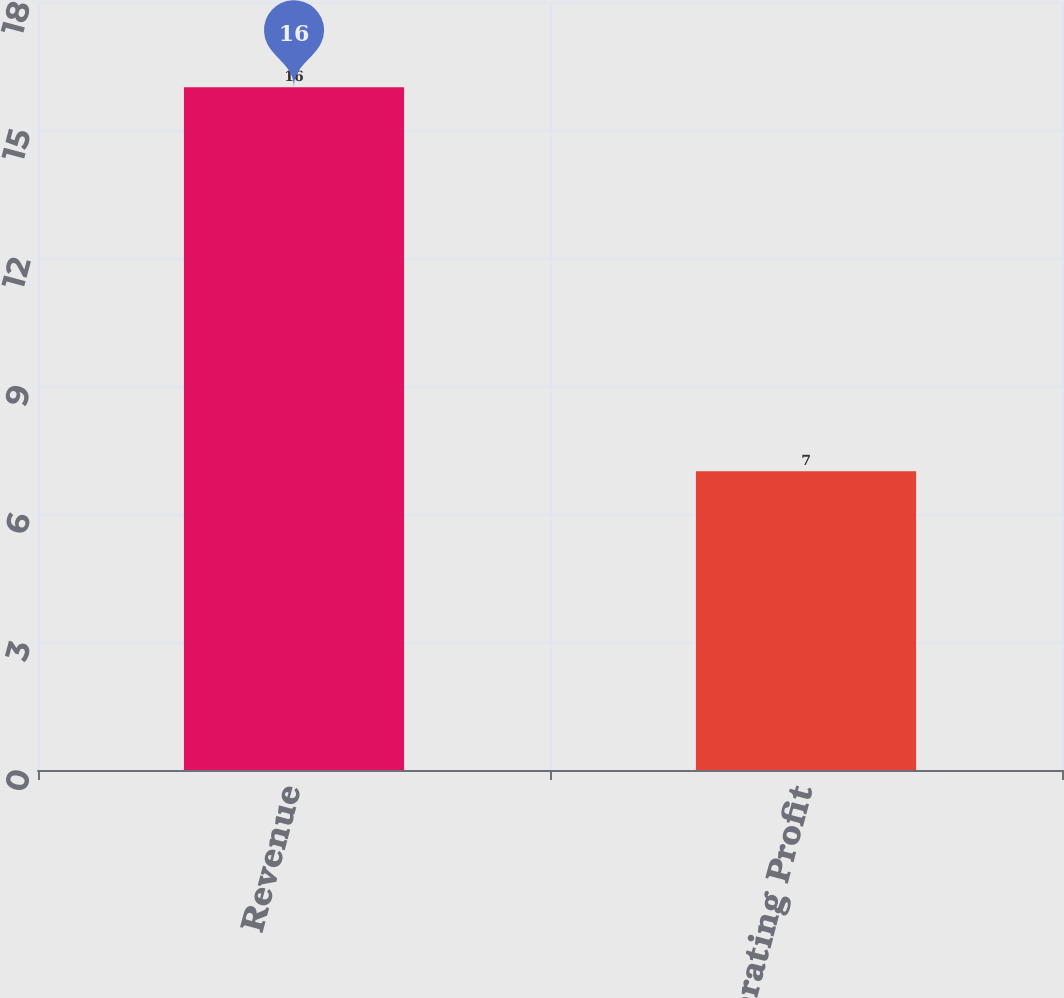Convert chart. <chart><loc_0><loc_0><loc_500><loc_500><bar_chart><fcel>Revenue<fcel>Operating Profit<nl><fcel>16<fcel>7<nl></chart> 